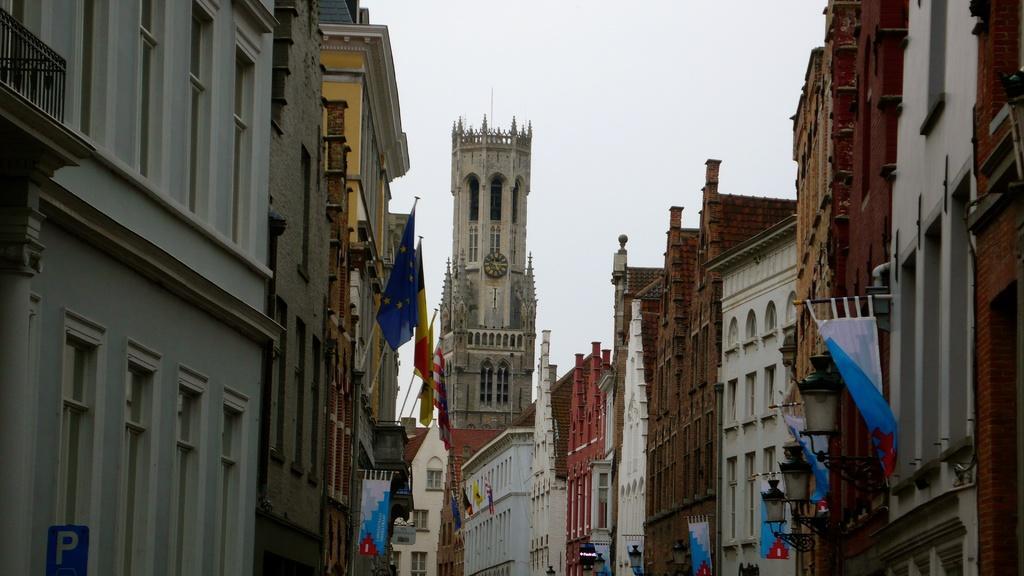How would you summarize this image in a sentence or two? These are the buildings, there are flags on it. At the top it is the sky. 